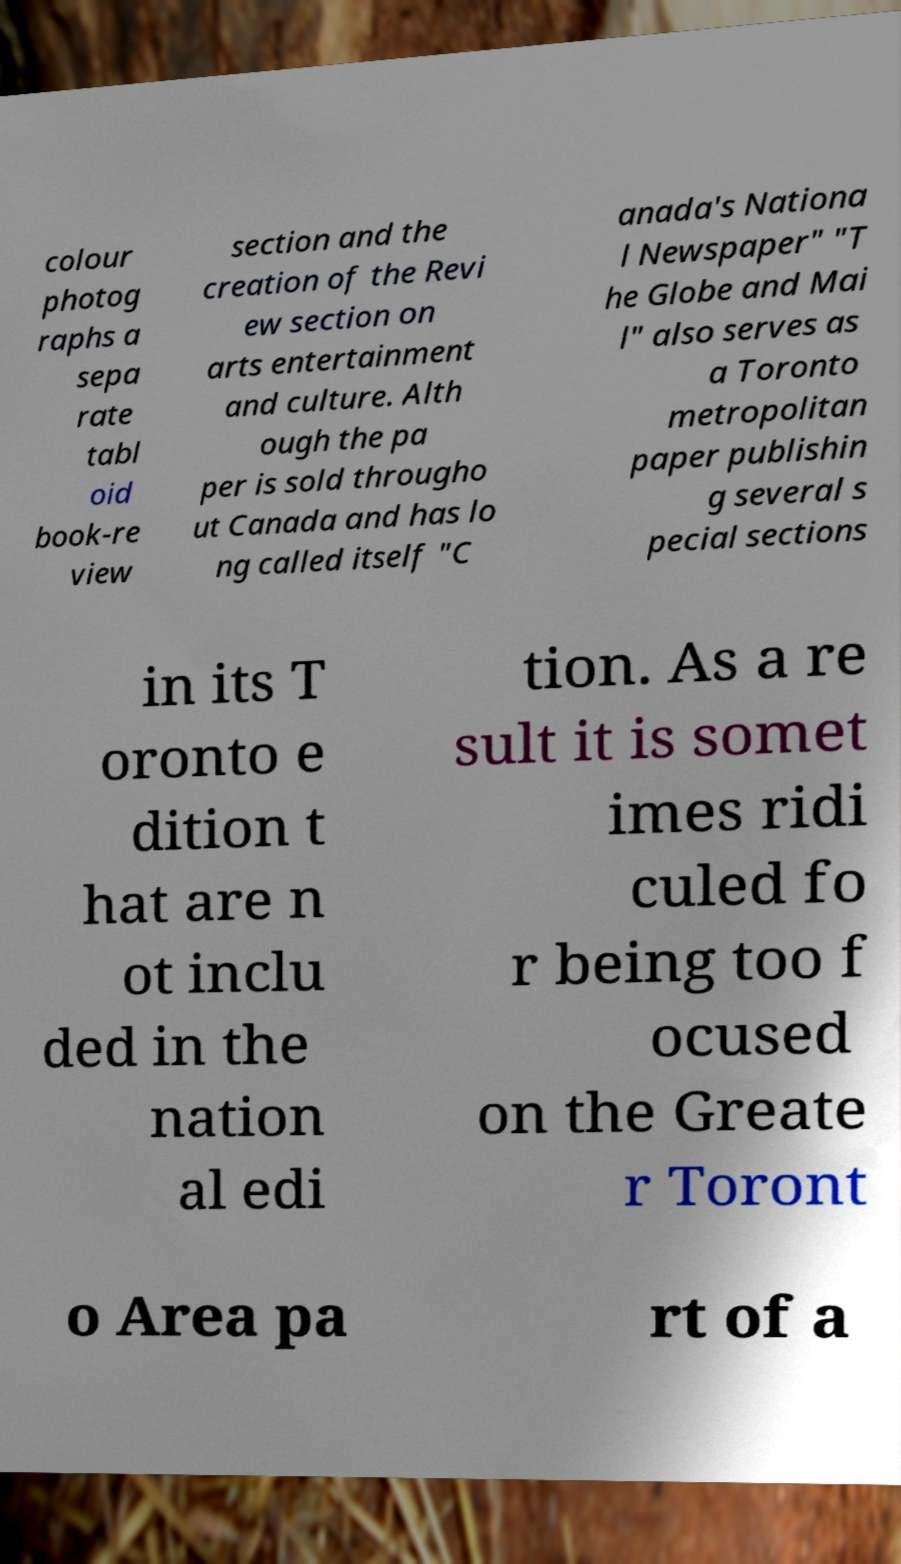Could you assist in decoding the text presented in this image and type it out clearly? colour photog raphs a sepa rate tabl oid book-re view section and the creation of the Revi ew section on arts entertainment and culture. Alth ough the pa per is sold througho ut Canada and has lo ng called itself "C anada's Nationa l Newspaper" "T he Globe and Mai l" also serves as a Toronto metropolitan paper publishin g several s pecial sections in its T oronto e dition t hat are n ot inclu ded in the nation al edi tion. As a re sult it is somet imes ridi culed fo r being too f ocused on the Greate r Toront o Area pa rt of a 